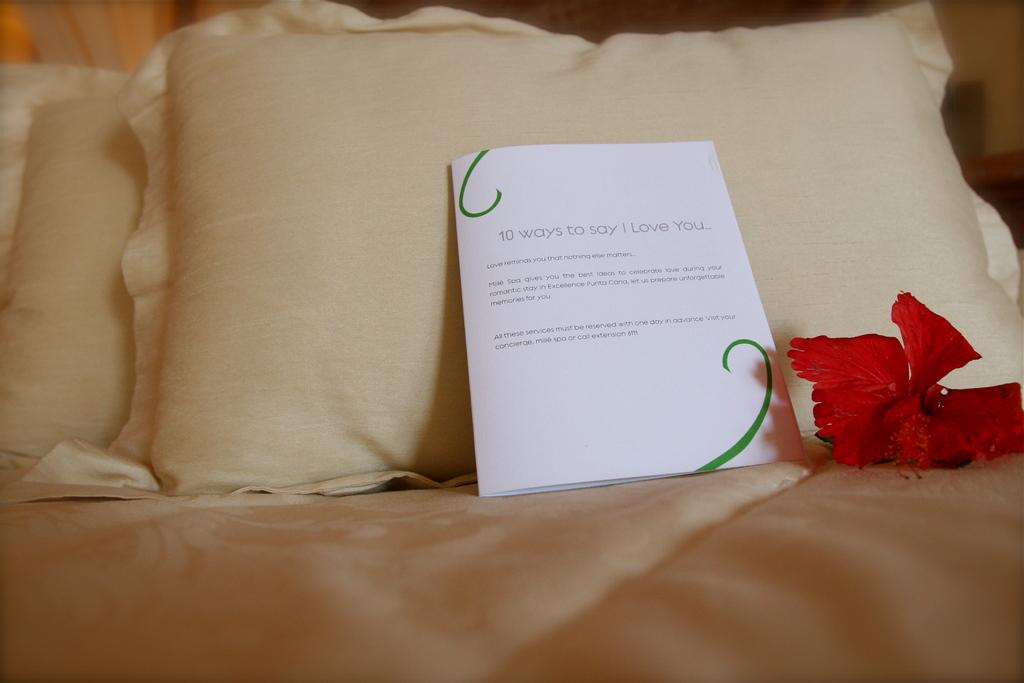What piece of furniture is present in the image? There is a bed in the image. What decorative item can be seen on the bed? There is a flower on the bed. What are the soft, cushioned items on the bed used for? There are pillows on the bed, which are used for support and comfort while sleeping or resting. What type of paper item is on the bed with writing on it? There is a card on the bed, and it has text on it. How does the wind affect the flower on the bed in the image? There is no wind present in the image, so the flower is not affected by it. What type of glue is used to attach the receipt to the card in the image? There is no receipt present in the image, so we cannot determine what type of glue might be used. 